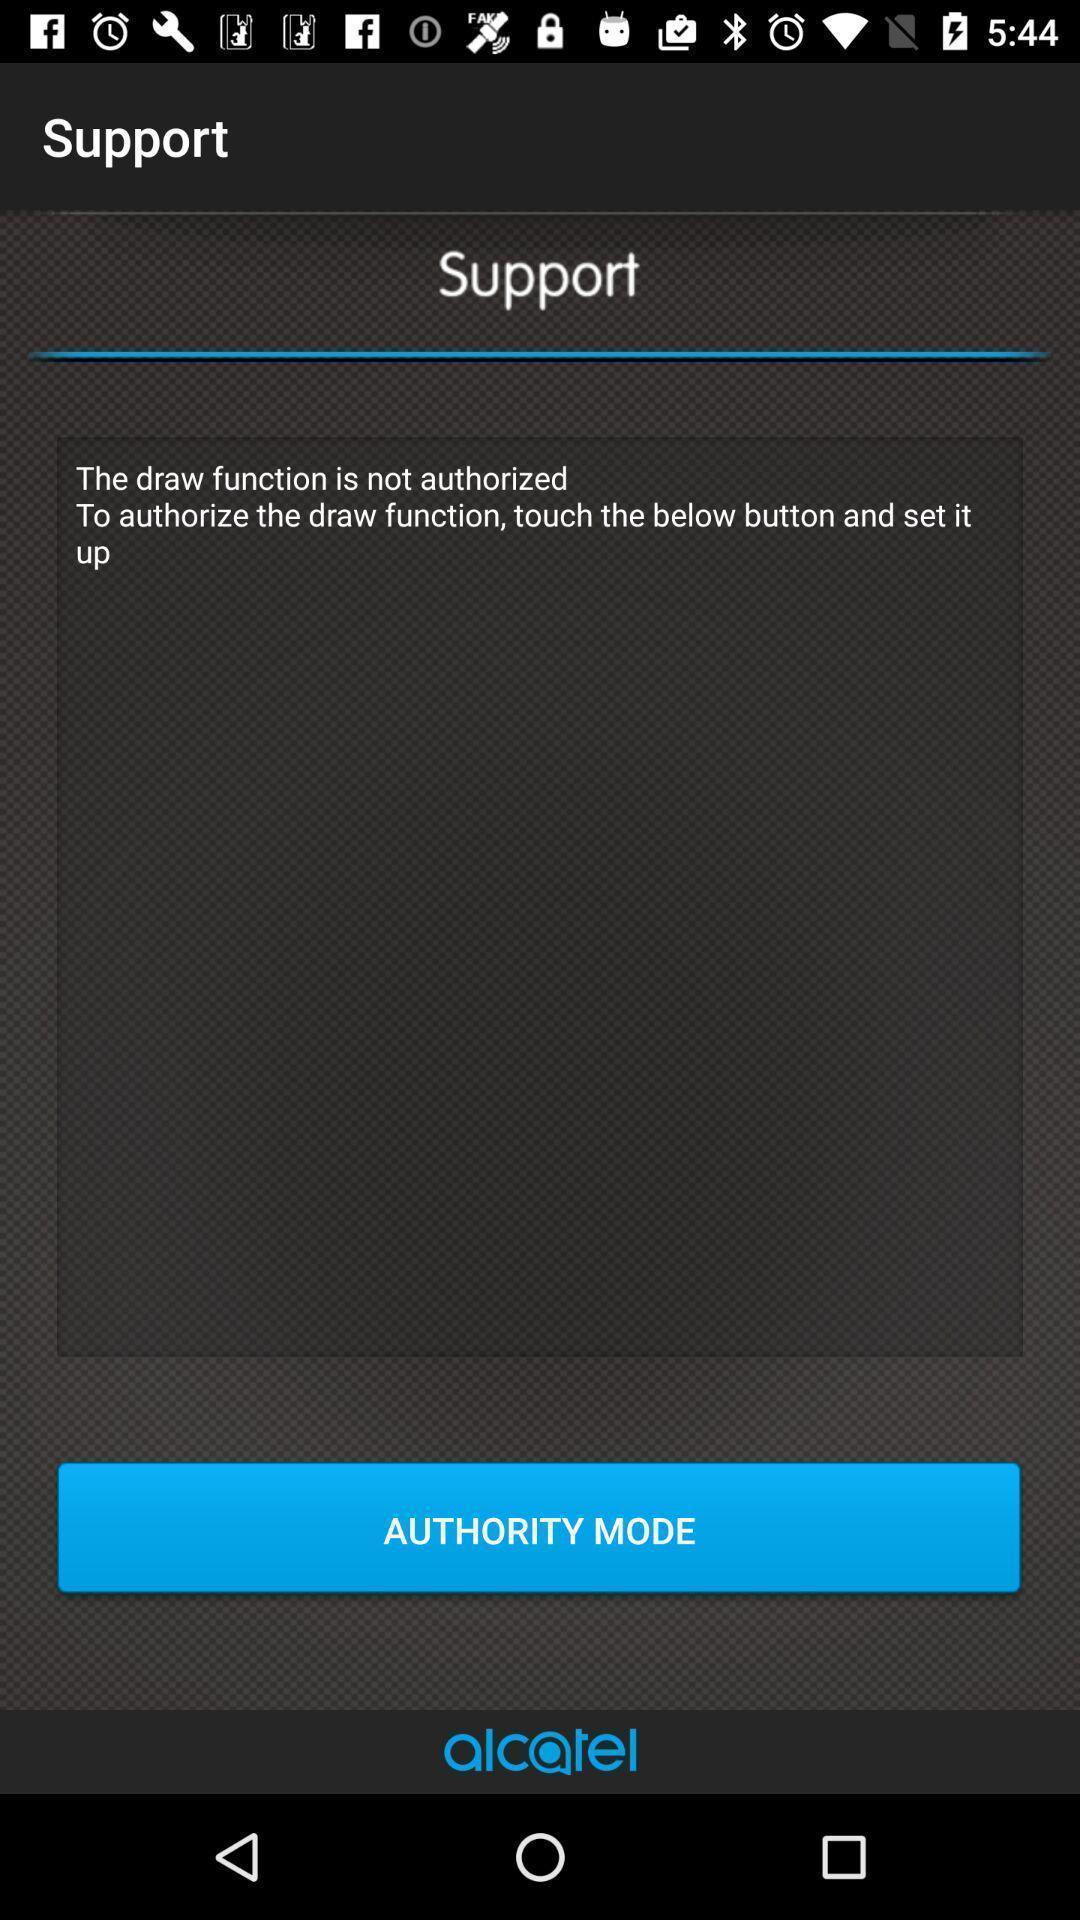Provide a detailed account of this screenshot. Page displaying to select authority mode. 